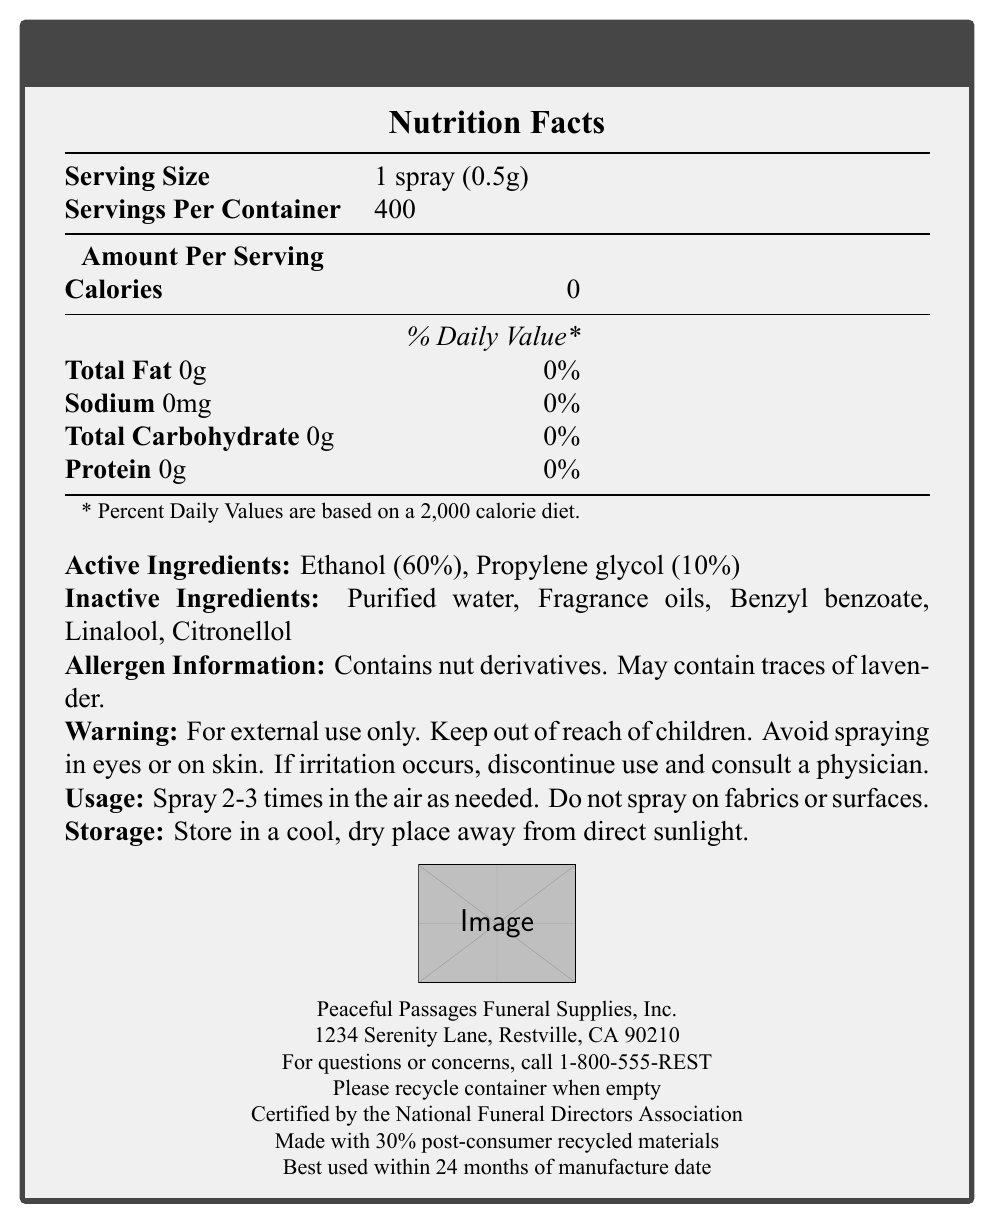what is the serving size? The document states that the serving size is 1 spray, which is quantified as 0.5g.
Answer: 1 spray (0.5g) How many servings are there per container? The document mentions that there are 400 servings per container.
Answer: 400 What are the active ingredients in the EternalFresh Air Freshener? Under the "Active Ingredients" section, Ethanol and Propylene glycol, along with their respective percentages, are listed.
Answer: Ethanol (60%), Propylene glycol (10%) What is the manufacturer's name and address? The information about the manufacturer, including the address, is listed at the end of the document.
Answer: Peaceful Passages Funeral Supplies, Inc., 1234 Serenity Lane, Restville, CA 90210 What should you do if irritation occurs? The warning section advises discontinuing use and consulting a physician if irritation occurs.
Answer: Discontinue use and consult a physician Which of these ingredients is NOT listed as either active or inactive in the product? A. Benzyl benzoate B. Lavender C. Citronellol D. Propylene glycol Benzyl benzoate, Citronellol, and Propylene glycol are listed as ingredients, while Lavender is mentioned only in the allergen information section.
Answer: B Which of the following are top notes in the fragrance? A. Eucalyptus and Lemon B. Lavender and Rosemary C. Cedarwood and Vanilla The document lists Eucalyptus and Lemon as the top notes in the fragrance.
Answer: A Is the container recyclable? The document indicates that the container should be recycled when empty.
Answer: Yes Summarize the main details provided in the Nutrition Facts Label for the EternalFresh Air Freshener. This summary encapsulates all the major points: product name, nutritional content, ingredients, allergen information, warnings, usage/storage instructions, and manufacturer details.
Answer: EternalFresh Air Freshener, using serving size of 1 spray (0.5g) and 400 servings per container, contains no calories, fat, sodium, carbohydrates, or protein. It includes active ingredients Ethanol (60%) and Propylene glycol (10%), and inactive ingredients such as purified water, fragrance oils, benzyl benzoate, linalool, and citronellol. It contains nut derivatives and may contain lavender traces. For external use only, with specific storage and usage instructions. Manufactured by Peaceful Passages Funeral Supplies, Inc. What is the percentage of the active ingredient Ethanol in EternalFresh Air Freshener? The document lists Ethanol as being 60% of the active ingredients.
Answer: 60% How should the EternalFresh Air Freshener be used? The usage instructions specifically state to spray 2-3 times in the air and to avoid spraying on fabrics or surfaces.
Answer: Spray 2-3 times in the air as needed. Do not spray on fabrics or surfaces. Can you determine the exact manufacture date of the product from the document? The document states the product should be used within 24 months of the manufacture date but does not provide the actual manufacture date.
Answer: Cannot be determined 